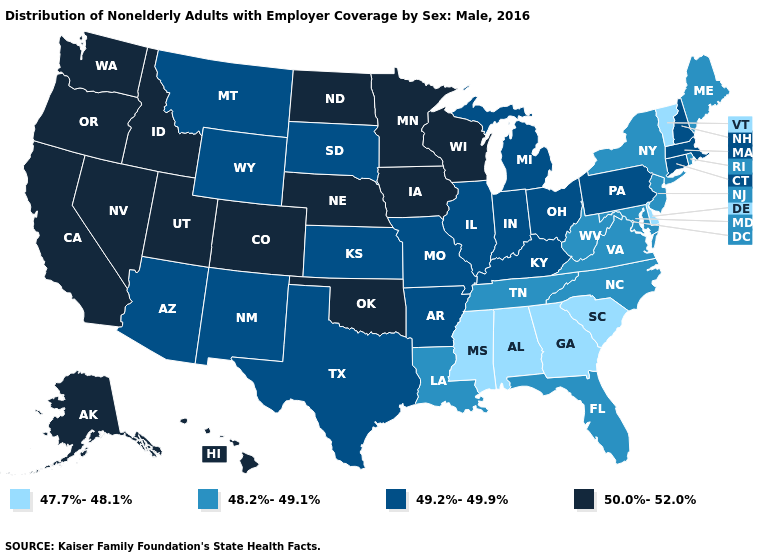Does Missouri have the lowest value in the MidWest?
Be succinct. Yes. What is the value of Minnesota?
Quick response, please. 50.0%-52.0%. Name the states that have a value in the range 50.0%-52.0%?
Quick response, please. Alaska, California, Colorado, Hawaii, Idaho, Iowa, Minnesota, Nebraska, Nevada, North Dakota, Oklahoma, Oregon, Utah, Washington, Wisconsin. What is the value of Michigan?
Give a very brief answer. 49.2%-49.9%. What is the highest value in states that border Louisiana?
Answer briefly. 49.2%-49.9%. Name the states that have a value in the range 47.7%-48.1%?
Short answer required. Alabama, Delaware, Georgia, Mississippi, South Carolina, Vermont. Among the states that border Idaho , which have the lowest value?
Concise answer only. Montana, Wyoming. What is the lowest value in the South?
Write a very short answer. 47.7%-48.1%. Which states have the highest value in the USA?
Quick response, please. Alaska, California, Colorado, Hawaii, Idaho, Iowa, Minnesota, Nebraska, Nevada, North Dakota, Oklahoma, Oregon, Utah, Washington, Wisconsin. Name the states that have a value in the range 48.2%-49.1%?
Short answer required. Florida, Louisiana, Maine, Maryland, New Jersey, New York, North Carolina, Rhode Island, Tennessee, Virginia, West Virginia. What is the highest value in the West ?
Short answer required. 50.0%-52.0%. Is the legend a continuous bar?
Quick response, please. No. What is the value of Alabama?
Concise answer only. 47.7%-48.1%. Does the map have missing data?
Write a very short answer. No. 